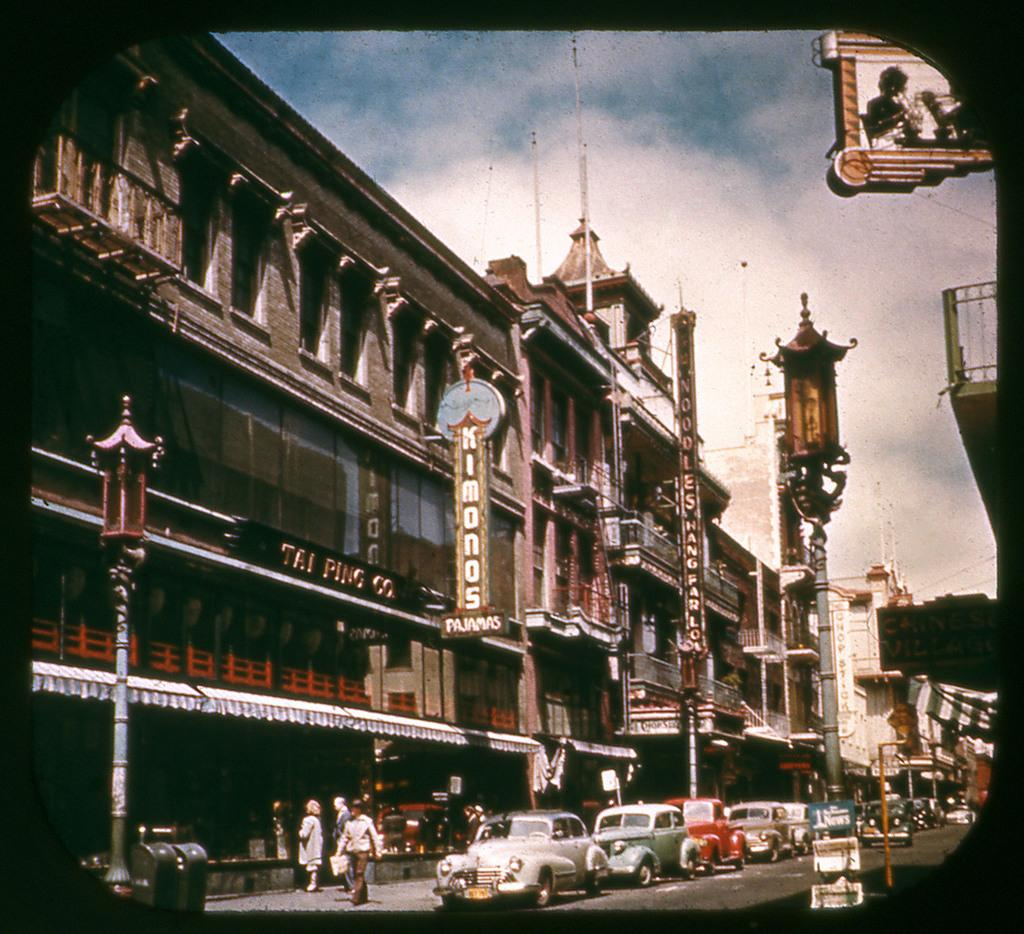<image>
Give a short and clear explanation of the subsequent image. Cars driving by a shop advertising Kimonos and pajamas 